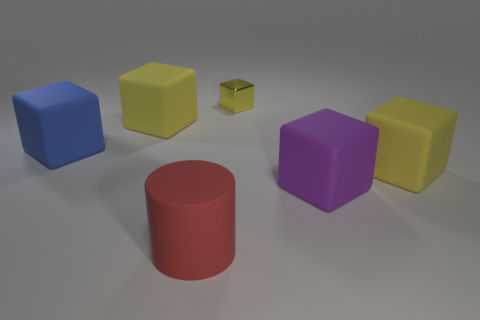Is there anything else that has the same material as the tiny block?
Give a very brief answer. No. Does the blue matte thing have the same shape as the metal thing?
Offer a terse response. Yes. How many other things are there of the same size as the cylinder?
Your answer should be compact. 4. The big matte cylinder is what color?
Offer a very short reply. Red. What number of big things are spheres or blue things?
Make the answer very short. 1. There is a yellow rubber thing on the right side of the big red rubber cylinder; is it the same size as the yellow thing that is on the left side of the red matte thing?
Provide a short and direct response. Yes. There is a yellow shiny thing that is the same shape as the blue rubber object; what size is it?
Give a very brief answer. Small. Are there more blue rubber blocks on the right side of the tiny metallic thing than small metallic blocks in front of the large purple block?
Your response must be concise. No. What material is the block that is behind the blue matte block and left of the big cylinder?
Offer a terse response. Rubber. There is a small metal object that is the same shape as the large blue matte object; what color is it?
Offer a very short reply. Yellow. 